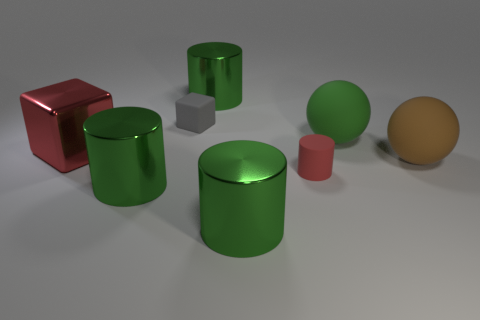How does the matte texture of the green sphere compare to the textures of the other objects? The green sphere's matte texture does not reflect light sharply, giving it a soft, evenly lit appearance. In contrast, the other objects like the red cube and the metallic cylinders exhibit varying degrees of reflectivity, with highlights and more defined specular reflections that indicate different surface properties. 